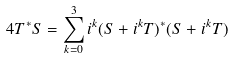Convert formula to latex. <formula><loc_0><loc_0><loc_500><loc_500>4 T ^ { * } S = \sum _ { k = 0 } ^ { 3 } i ^ { k } ( S + i ^ { k } T ) ^ { * } ( S + i ^ { k } T )</formula> 